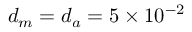<formula> <loc_0><loc_0><loc_500><loc_500>d _ { m } = d _ { a } = 5 \times 1 0 ^ { - 2 }</formula> 